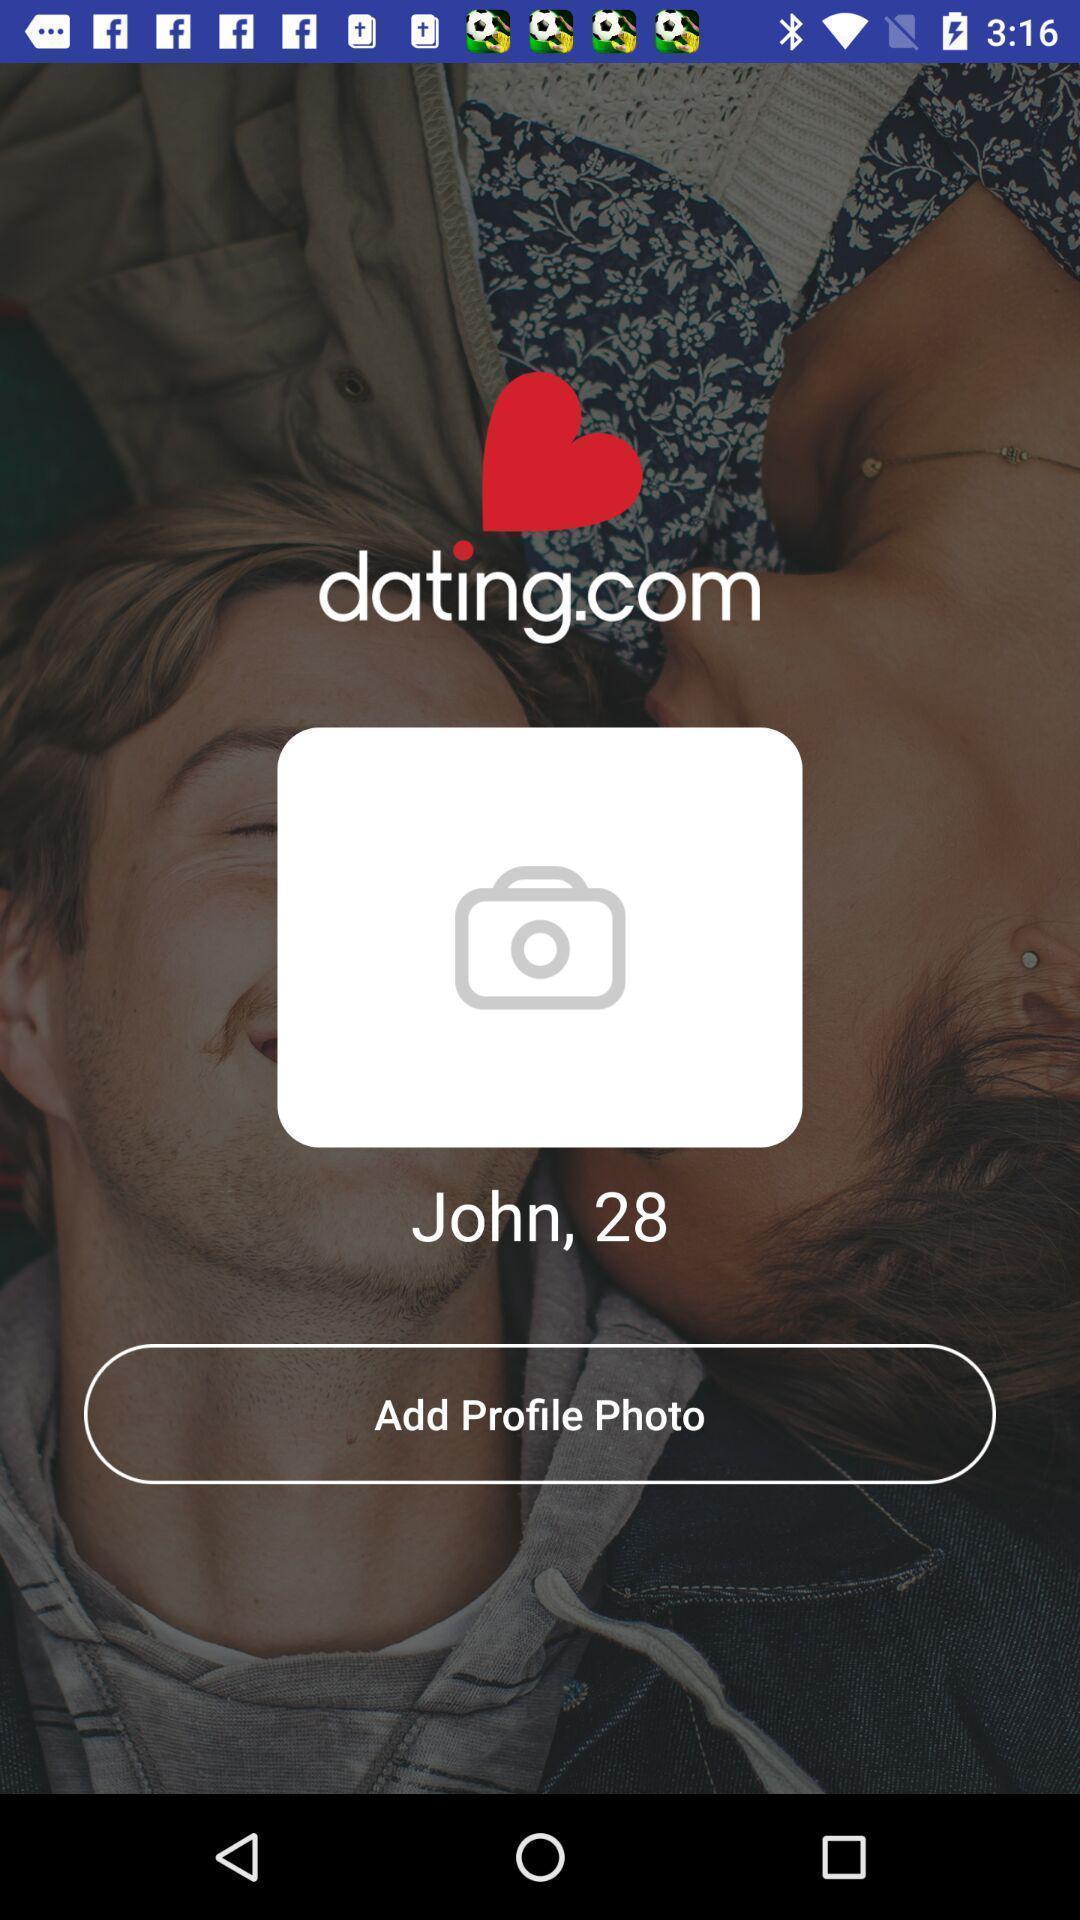Provide a description of this screenshot. Page displays to add a profile photo in social app. 